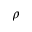Convert formula to latex. <formula><loc_0><loc_0><loc_500><loc_500>\rho</formula> 